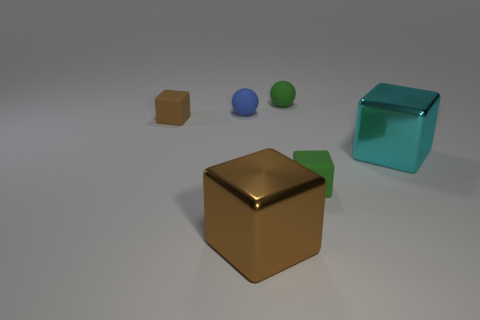Subtract all large cyan shiny blocks. How many blocks are left? 3 Subtract all purple spheres. How many brown blocks are left? 2 Subtract all cyan cubes. How many cubes are left? 3 Subtract 2 blocks. How many blocks are left? 2 Add 4 tiny blue matte spheres. How many objects exist? 10 Subtract all blocks. How many objects are left? 2 Subtract all cyan balls. Subtract all gray cubes. How many balls are left? 2 Add 1 brown cubes. How many brown cubes are left? 3 Add 3 small things. How many small things exist? 7 Subtract 0 brown balls. How many objects are left? 6 